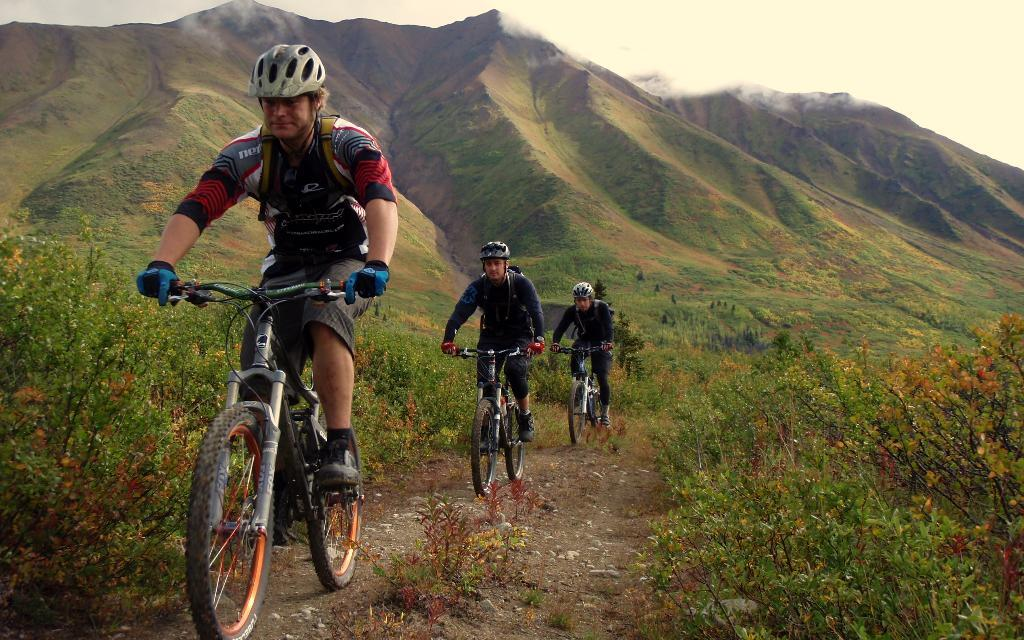How many people are in the image? There are three people in the image. What are the people doing in the image? The people are riding bicycles. What safety precaution are the people taking while riding bicycles? The people are wearing helmets. Can you describe any other objects or elements in the image? There are helmets visible in the background and plants in the image. What time of day is it in the image, considering the people are sleeping? The people are not sleeping in the image; they are riding bicycles. How many geese are present in the image? There are no geese present in the image. 